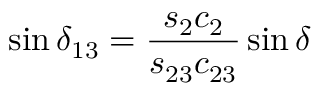<formula> <loc_0><loc_0><loc_500><loc_500>\sin \delta _ { 1 3 } = \frac { s _ { 2 } c _ { 2 } } { s _ { 2 3 } c _ { 2 3 } } \sin \delta</formula> 